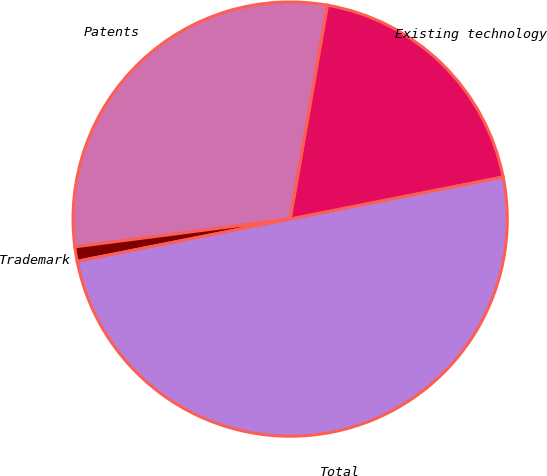Convert chart to OTSL. <chart><loc_0><loc_0><loc_500><loc_500><pie_chart><fcel>Existing technology<fcel>Patents<fcel>Trademark<fcel>Total<nl><fcel>19.15%<fcel>29.79%<fcel>1.07%<fcel>50.0%<nl></chart> 